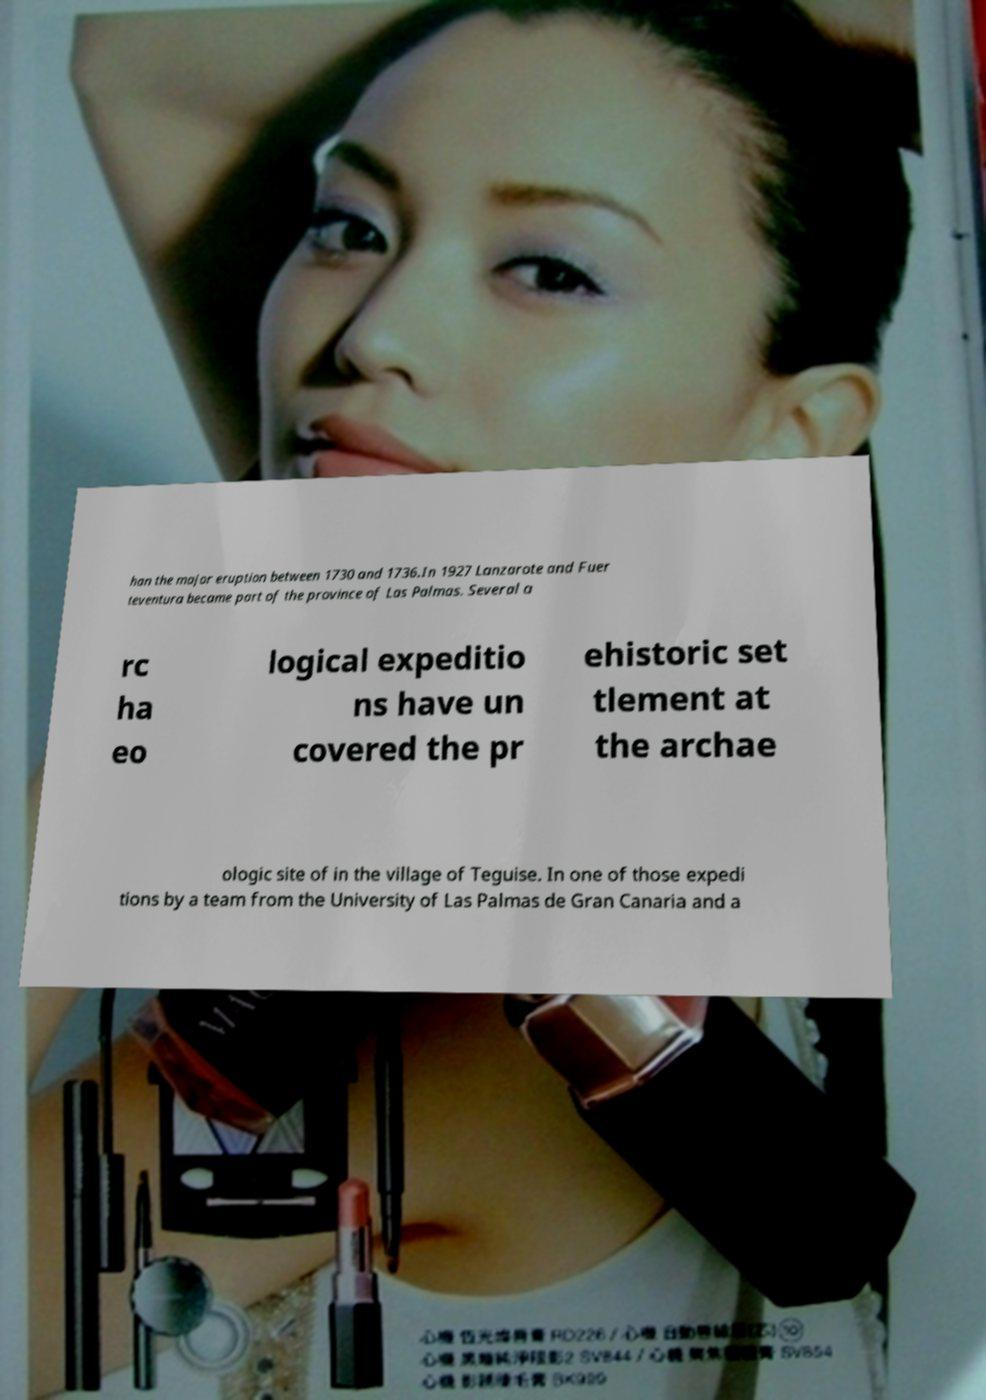For documentation purposes, I need the text within this image transcribed. Could you provide that? han the major eruption between 1730 and 1736.In 1927 Lanzarote and Fuer teventura became part of the province of Las Palmas. Several a rc ha eo logical expeditio ns have un covered the pr ehistoric set tlement at the archae ologic site of in the village of Teguise. In one of those expedi tions by a team from the University of Las Palmas de Gran Canaria and a 